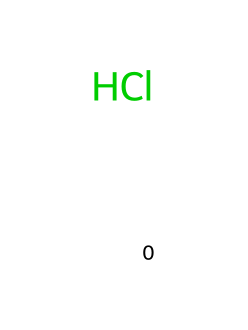What is the molecular formula of hydrochloric acid? The SMILES representation of hydrochloric acid is `[H]Cl`, which indicates that it consists of one hydrogen atom and one chlorine atom. Therefore, the molecular formula is determined by counting these atoms.
Answer: HCl How many atoms are present in hydrochloric acid? From the SMILES notation `[H]Cl`, there is one hydrogen atom and one chlorine atom, which totals to two atoms in the molecule.
Answer: 2 What type of chemical is hydrochloric acid? Hydrochloric acid, represented by the structure `[H]Cl`, is classified as an acid because it can donate protons (H+) in an aqueous solution, a characteristic behavior of acids.
Answer: acid Which acid is commonly associated with stomach acid reflux? Hydrochloric acid (HCl) is the primary acid that contributes to stomach acidity and is the acid involved in stomach acid reflux, indicated by the presence of HCl in the digestive system.
Answer: hydrochloric acid How many covalent bonds are in hydrochloric acid? In the structure of hydrochloric acid represented as `[H]Cl`, there is one covalent bond formed between the hydrogen atom and the chlorine atom, indicating a single bond connection between them.
Answer: 1 What ion does hydrochloric acid produce in solution? When hydrochloric acid dissociates in water, it produces hydrogen ions (H+) and chloride ions (Cl-), indicating that H+ is a product formed from its dissociation.
Answer: hydrogen ion What is the state of hydrochloric acid at room temperature? Hydrochloric acid is typically found as a gaseous form (HCl gas) or as an aqueous solution when dissolved in water. The presence of this chemical in solution can infer its common liquid state at room temperature.
Answer: gas or liquid 